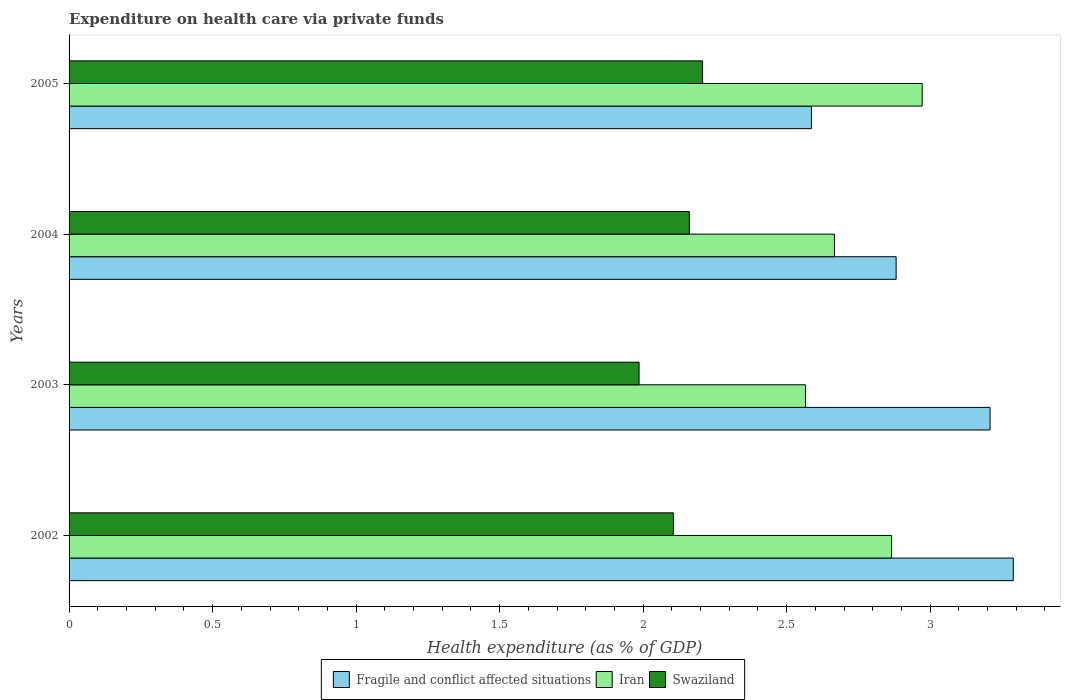How many different coloured bars are there?
Provide a short and direct response. 3. How many groups of bars are there?
Offer a very short reply. 4. Are the number of bars on each tick of the Y-axis equal?
Offer a very short reply. Yes. How many bars are there on the 1st tick from the bottom?
Your answer should be very brief. 3. What is the label of the 4th group of bars from the top?
Make the answer very short. 2002. What is the expenditure made on health care in Fragile and conflict affected situations in 2003?
Your answer should be compact. 3.21. Across all years, what is the maximum expenditure made on health care in Iran?
Offer a terse response. 2.97. Across all years, what is the minimum expenditure made on health care in Iran?
Provide a short and direct response. 2.57. In which year was the expenditure made on health care in Iran maximum?
Provide a succinct answer. 2005. In which year was the expenditure made on health care in Swaziland minimum?
Provide a short and direct response. 2003. What is the total expenditure made on health care in Iran in the graph?
Your answer should be very brief. 11.07. What is the difference between the expenditure made on health care in Swaziland in 2003 and that in 2004?
Your answer should be compact. -0.18. What is the difference between the expenditure made on health care in Fragile and conflict affected situations in 2003 and the expenditure made on health care in Iran in 2002?
Offer a terse response. 0.34. What is the average expenditure made on health care in Iran per year?
Your response must be concise. 2.77. In the year 2002, what is the difference between the expenditure made on health care in Fragile and conflict affected situations and expenditure made on health care in Iran?
Your response must be concise. 0.42. What is the ratio of the expenditure made on health care in Fragile and conflict affected situations in 2003 to that in 2004?
Offer a very short reply. 1.11. Is the expenditure made on health care in Fragile and conflict affected situations in 2003 less than that in 2005?
Offer a very short reply. No. Is the difference between the expenditure made on health care in Fragile and conflict affected situations in 2002 and 2004 greater than the difference between the expenditure made on health care in Iran in 2002 and 2004?
Offer a very short reply. Yes. What is the difference between the highest and the second highest expenditure made on health care in Iran?
Your answer should be compact. 0.11. What is the difference between the highest and the lowest expenditure made on health care in Iran?
Provide a short and direct response. 0.41. What does the 3rd bar from the top in 2002 represents?
Provide a short and direct response. Fragile and conflict affected situations. What does the 2nd bar from the bottom in 2004 represents?
Ensure brevity in your answer.  Iran. Is it the case that in every year, the sum of the expenditure made on health care in Fragile and conflict affected situations and expenditure made on health care in Iran is greater than the expenditure made on health care in Swaziland?
Your answer should be compact. Yes. How many bars are there?
Ensure brevity in your answer.  12. What is the difference between two consecutive major ticks on the X-axis?
Keep it short and to the point. 0.5. Does the graph contain grids?
Your answer should be very brief. No. What is the title of the graph?
Your response must be concise. Expenditure on health care via private funds. What is the label or title of the X-axis?
Your response must be concise. Health expenditure (as % of GDP). What is the Health expenditure (as % of GDP) of Fragile and conflict affected situations in 2002?
Provide a short and direct response. 3.29. What is the Health expenditure (as % of GDP) in Iran in 2002?
Keep it short and to the point. 2.87. What is the Health expenditure (as % of GDP) in Swaziland in 2002?
Provide a short and direct response. 2.11. What is the Health expenditure (as % of GDP) in Fragile and conflict affected situations in 2003?
Your answer should be very brief. 3.21. What is the Health expenditure (as % of GDP) in Iran in 2003?
Provide a succinct answer. 2.57. What is the Health expenditure (as % of GDP) of Swaziland in 2003?
Keep it short and to the point. 1.99. What is the Health expenditure (as % of GDP) in Fragile and conflict affected situations in 2004?
Provide a short and direct response. 2.88. What is the Health expenditure (as % of GDP) in Iran in 2004?
Keep it short and to the point. 2.67. What is the Health expenditure (as % of GDP) in Swaziland in 2004?
Give a very brief answer. 2.16. What is the Health expenditure (as % of GDP) of Fragile and conflict affected situations in 2005?
Provide a succinct answer. 2.59. What is the Health expenditure (as % of GDP) of Iran in 2005?
Make the answer very short. 2.97. What is the Health expenditure (as % of GDP) in Swaziland in 2005?
Give a very brief answer. 2.21. Across all years, what is the maximum Health expenditure (as % of GDP) in Fragile and conflict affected situations?
Give a very brief answer. 3.29. Across all years, what is the maximum Health expenditure (as % of GDP) in Iran?
Provide a succinct answer. 2.97. Across all years, what is the maximum Health expenditure (as % of GDP) of Swaziland?
Keep it short and to the point. 2.21. Across all years, what is the minimum Health expenditure (as % of GDP) of Fragile and conflict affected situations?
Your answer should be compact. 2.59. Across all years, what is the minimum Health expenditure (as % of GDP) in Iran?
Your response must be concise. 2.57. Across all years, what is the minimum Health expenditure (as % of GDP) of Swaziland?
Your answer should be compact. 1.99. What is the total Health expenditure (as % of GDP) of Fragile and conflict affected situations in the graph?
Your answer should be very brief. 11.97. What is the total Health expenditure (as % of GDP) in Iran in the graph?
Your answer should be very brief. 11.07. What is the total Health expenditure (as % of GDP) of Swaziland in the graph?
Your response must be concise. 8.46. What is the difference between the Health expenditure (as % of GDP) of Fragile and conflict affected situations in 2002 and that in 2003?
Give a very brief answer. 0.08. What is the difference between the Health expenditure (as % of GDP) of Iran in 2002 and that in 2003?
Provide a short and direct response. 0.3. What is the difference between the Health expenditure (as % of GDP) of Swaziland in 2002 and that in 2003?
Keep it short and to the point. 0.12. What is the difference between the Health expenditure (as % of GDP) of Fragile and conflict affected situations in 2002 and that in 2004?
Give a very brief answer. 0.41. What is the difference between the Health expenditure (as % of GDP) in Iran in 2002 and that in 2004?
Give a very brief answer. 0.2. What is the difference between the Health expenditure (as % of GDP) in Swaziland in 2002 and that in 2004?
Your answer should be compact. -0.06. What is the difference between the Health expenditure (as % of GDP) of Fragile and conflict affected situations in 2002 and that in 2005?
Provide a succinct answer. 0.7. What is the difference between the Health expenditure (as % of GDP) in Iran in 2002 and that in 2005?
Make the answer very short. -0.11. What is the difference between the Health expenditure (as % of GDP) in Swaziland in 2002 and that in 2005?
Your answer should be compact. -0.1. What is the difference between the Health expenditure (as % of GDP) in Fragile and conflict affected situations in 2003 and that in 2004?
Provide a succinct answer. 0.33. What is the difference between the Health expenditure (as % of GDP) in Iran in 2003 and that in 2004?
Your response must be concise. -0.1. What is the difference between the Health expenditure (as % of GDP) in Swaziland in 2003 and that in 2004?
Offer a terse response. -0.18. What is the difference between the Health expenditure (as % of GDP) in Fragile and conflict affected situations in 2003 and that in 2005?
Offer a terse response. 0.62. What is the difference between the Health expenditure (as % of GDP) in Iran in 2003 and that in 2005?
Offer a very short reply. -0.41. What is the difference between the Health expenditure (as % of GDP) in Swaziland in 2003 and that in 2005?
Your answer should be compact. -0.22. What is the difference between the Health expenditure (as % of GDP) of Fragile and conflict affected situations in 2004 and that in 2005?
Keep it short and to the point. 0.3. What is the difference between the Health expenditure (as % of GDP) in Iran in 2004 and that in 2005?
Provide a short and direct response. -0.31. What is the difference between the Health expenditure (as % of GDP) in Swaziland in 2004 and that in 2005?
Provide a short and direct response. -0.05. What is the difference between the Health expenditure (as % of GDP) of Fragile and conflict affected situations in 2002 and the Health expenditure (as % of GDP) of Iran in 2003?
Provide a short and direct response. 0.72. What is the difference between the Health expenditure (as % of GDP) of Fragile and conflict affected situations in 2002 and the Health expenditure (as % of GDP) of Swaziland in 2003?
Provide a short and direct response. 1.3. What is the difference between the Health expenditure (as % of GDP) of Iran in 2002 and the Health expenditure (as % of GDP) of Swaziland in 2003?
Ensure brevity in your answer.  0.88. What is the difference between the Health expenditure (as % of GDP) in Fragile and conflict affected situations in 2002 and the Health expenditure (as % of GDP) in Iran in 2004?
Offer a very short reply. 0.62. What is the difference between the Health expenditure (as % of GDP) in Fragile and conflict affected situations in 2002 and the Health expenditure (as % of GDP) in Swaziland in 2004?
Give a very brief answer. 1.13. What is the difference between the Health expenditure (as % of GDP) of Iran in 2002 and the Health expenditure (as % of GDP) of Swaziland in 2004?
Ensure brevity in your answer.  0.7. What is the difference between the Health expenditure (as % of GDP) of Fragile and conflict affected situations in 2002 and the Health expenditure (as % of GDP) of Iran in 2005?
Offer a terse response. 0.32. What is the difference between the Health expenditure (as % of GDP) in Fragile and conflict affected situations in 2002 and the Health expenditure (as % of GDP) in Swaziland in 2005?
Keep it short and to the point. 1.08. What is the difference between the Health expenditure (as % of GDP) of Iran in 2002 and the Health expenditure (as % of GDP) of Swaziland in 2005?
Provide a short and direct response. 0.66. What is the difference between the Health expenditure (as % of GDP) of Fragile and conflict affected situations in 2003 and the Health expenditure (as % of GDP) of Iran in 2004?
Keep it short and to the point. 0.54. What is the difference between the Health expenditure (as % of GDP) in Fragile and conflict affected situations in 2003 and the Health expenditure (as % of GDP) in Swaziland in 2004?
Your response must be concise. 1.05. What is the difference between the Health expenditure (as % of GDP) in Iran in 2003 and the Health expenditure (as % of GDP) in Swaziland in 2004?
Your answer should be very brief. 0.4. What is the difference between the Health expenditure (as % of GDP) in Fragile and conflict affected situations in 2003 and the Health expenditure (as % of GDP) in Iran in 2005?
Your response must be concise. 0.24. What is the difference between the Health expenditure (as % of GDP) in Fragile and conflict affected situations in 2003 and the Health expenditure (as % of GDP) in Swaziland in 2005?
Ensure brevity in your answer.  1. What is the difference between the Health expenditure (as % of GDP) in Iran in 2003 and the Health expenditure (as % of GDP) in Swaziland in 2005?
Your answer should be very brief. 0.36. What is the difference between the Health expenditure (as % of GDP) in Fragile and conflict affected situations in 2004 and the Health expenditure (as % of GDP) in Iran in 2005?
Make the answer very short. -0.09. What is the difference between the Health expenditure (as % of GDP) in Fragile and conflict affected situations in 2004 and the Health expenditure (as % of GDP) in Swaziland in 2005?
Provide a succinct answer. 0.67. What is the difference between the Health expenditure (as % of GDP) in Iran in 2004 and the Health expenditure (as % of GDP) in Swaziland in 2005?
Offer a terse response. 0.46. What is the average Health expenditure (as % of GDP) of Fragile and conflict affected situations per year?
Offer a terse response. 2.99. What is the average Health expenditure (as % of GDP) in Iran per year?
Offer a very short reply. 2.77. What is the average Health expenditure (as % of GDP) of Swaziland per year?
Offer a terse response. 2.11. In the year 2002, what is the difference between the Health expenditure (as % of GDP) in Fragile and conflict affected situations and Health expenditure (as % of GDP) in Iran?
Offer a very short reply. 0.42. In the year 2002, what is the difference between the Health expenditure (as % of GDP) in Fragile and conflict affected situations and Health expenditure (as % of GDP) in Swaziland?
Keep it short and to the point. 1.18. In the year 2002, what is the difference between the Health expenditure (as % of GDP) in Iran and Health expenditure (as % of GDP) in Swaziland?
Your answer should be very brief. 0.76. In the year 2003, what is the difference between the Health expenditure (as % of GDP) in Fragile and conflict affected situations and Health expenditure (as % of GDP) in Iran?
Offer a terse response. 0.64. In the year 2003, what is the difference between the Health expenditure (as % of GDP) of Fragile and conflict affected situations and Health expenditure (as % of GDP) of Swaziland?
Your response must be concise. 1.22. In the year 2003, what is the difference between the Health expenditure (as % of GDP) of Iran and Health expenditure (as % of GDP) of Swaziland?
Keep it short and to the point. 0.58. In the year 2004, what is the difference between the Health expenditure (as % of GDP) in Fragile and conflict affected situations and Health expenditure (as % of GDP) in Iran?
Give a very brief answer. 0.21. In the year 2004, what is the difference between the Health expenditure (as % of GDP) of Fragile and conflict affected situations and Health expenditure (as % of GDP) of Swaziland?
Provide a short and direct response. 0.72. In the year 2004, what is the difference between the Health expenditure (as % of GDP) of Iran and Health expenditure (as % of GDP) of Swaziland?
Your response must be concise. 0.51. In the year 2005, what is the difference between the Health expenditure (as % of GDP) in Fragile and conflict affected situations and Health expenditure (as % of GDP) in Iran?
Your answer should be very brief. -0.39. In the year 2005, what is the difference between the Health expenditure (as % of GDP) of Fragile and conflict affected situations and Health expenditure (as % of GDP) of Swaziland?
Give a very brief answer. 0.38. In the year 2005, what is the difference between the Health expenditure (as % of GDP) of Iran and Health expenditure (as % of GDP) of Swaziland?
Provide a short and direct response. 0.77. What is the ratio of the Health expenditure (as % of GDP) of Fragile and conflict affected situations in 2002 to that in 2003?
Offer a very short reply. 1.03. What is the ratio of the Health expenditure (as % of GDP) in Iran in 2002 to that in 2003?
Provide a short and direct response. 1.12. What is the ratio of the Health expenditure (as % of GDP) of Swaziland in 2002 to that in 2003?
Keep it short and to the point. 1.06. What is the ratio of the Health expenditure (as % of GDP) of Fragile and conflict affected situations in 2002 to that in 2004?
Give a very brief answer. 1.14. What is the ratio of the Health expenditure (as % of GDP) of Iran in 2002 to that in 2004?
Your answer should be compact. 1.07. What is the ratio of the Health expenditure (as % of GDP) in Swaziland in 2002 to that in 2004?
Your response must be concise. 0.97. What is the ratio of the Health expenditure (as % of GDP) in Fragile and conflict affected situations in 2002 to that in 2005?
Ensure brevity in your answer.  1.27. What is the ratio of the Health expenditure (as % of GDP) of Iran in 2002 to that in 2005?
Your response must be concise. 0.96. What is the ratio of the Health expenditure (as % of GDP) of Swaziland in 2002 to that in 2005?
Provide a short and direct response. 0.95. What is the ratio of the Health expenditure (as % of GDP) in Fragile and conflict affected situations in 2003 to that in 2004?
Provide a succinct answer. 1.11. What is the ratio of the Health expenditure (as % of GDP) in Iran in 2003 to that in 2004?
Provide a succinct answer. 0.96. What is the ratio of the Health expenditure (as % of GDP) of Swaziland in 2003 to that in 2004?
Your answer should be compact. 0.92. What is the ratio of the Health expenditure (as % of GDP) of Fragile and conflict affected situations in 2003 to that in 2005?
Provide a short and direct response. 1.24. What is the ratio of the Health expenditure (as % of GDP) in Iran in 2003 to that in 2005?
Give a very brief answer. 0.86. What is the ratio of the Health expenditure (as % of GDP) in Swaziland in 2003 to that in 2005?
Provide a succinct answer. 0.9. What is the ratio of the Health expenditure (as % of GDP) of Fragile and conflict affected situations in 2004 to that in 2005?
Your response must be concise. 1.11. What is the ratio of the Health expenditure (as % of GDP) of Iran in 2004 to that in 2005?
Keep it short and to the point. 0.9. What is the ratio of the Health expenditure (as % of GDP) of Swaziland in 2004 to that in 2005?
Your answer should be very brief. 0.98. What is the difference between the highest and the second highest Health expenditure (as % of GDP) in Fragile and conflict affected situations?
Provide a succinct answer. 0.08. What is the difference between the highest and the second highest Health expenditure (as % of GDP) in Iran?
Ensure brevity in your answer.  0.11. What is the difference between the highest and the second highest Health expenditure (as % of GDP) of Swaziland?
Provide a succinct answer. 0.05. What is the difference between the highest and the lowest Health expenditure (as % of GDP) of Fragile and conflict affected situations?
Ensure brevity in your answer.  0.7. What is the difference between the highest and the lowest Health expenditure (as % of GDP) in Iran?
Offer a terse response. 0.41. What is the difference between the highest and the lowest Health expenditure (as % of GDP) of Swaziland?
Offer a very short reply. 0.22. 